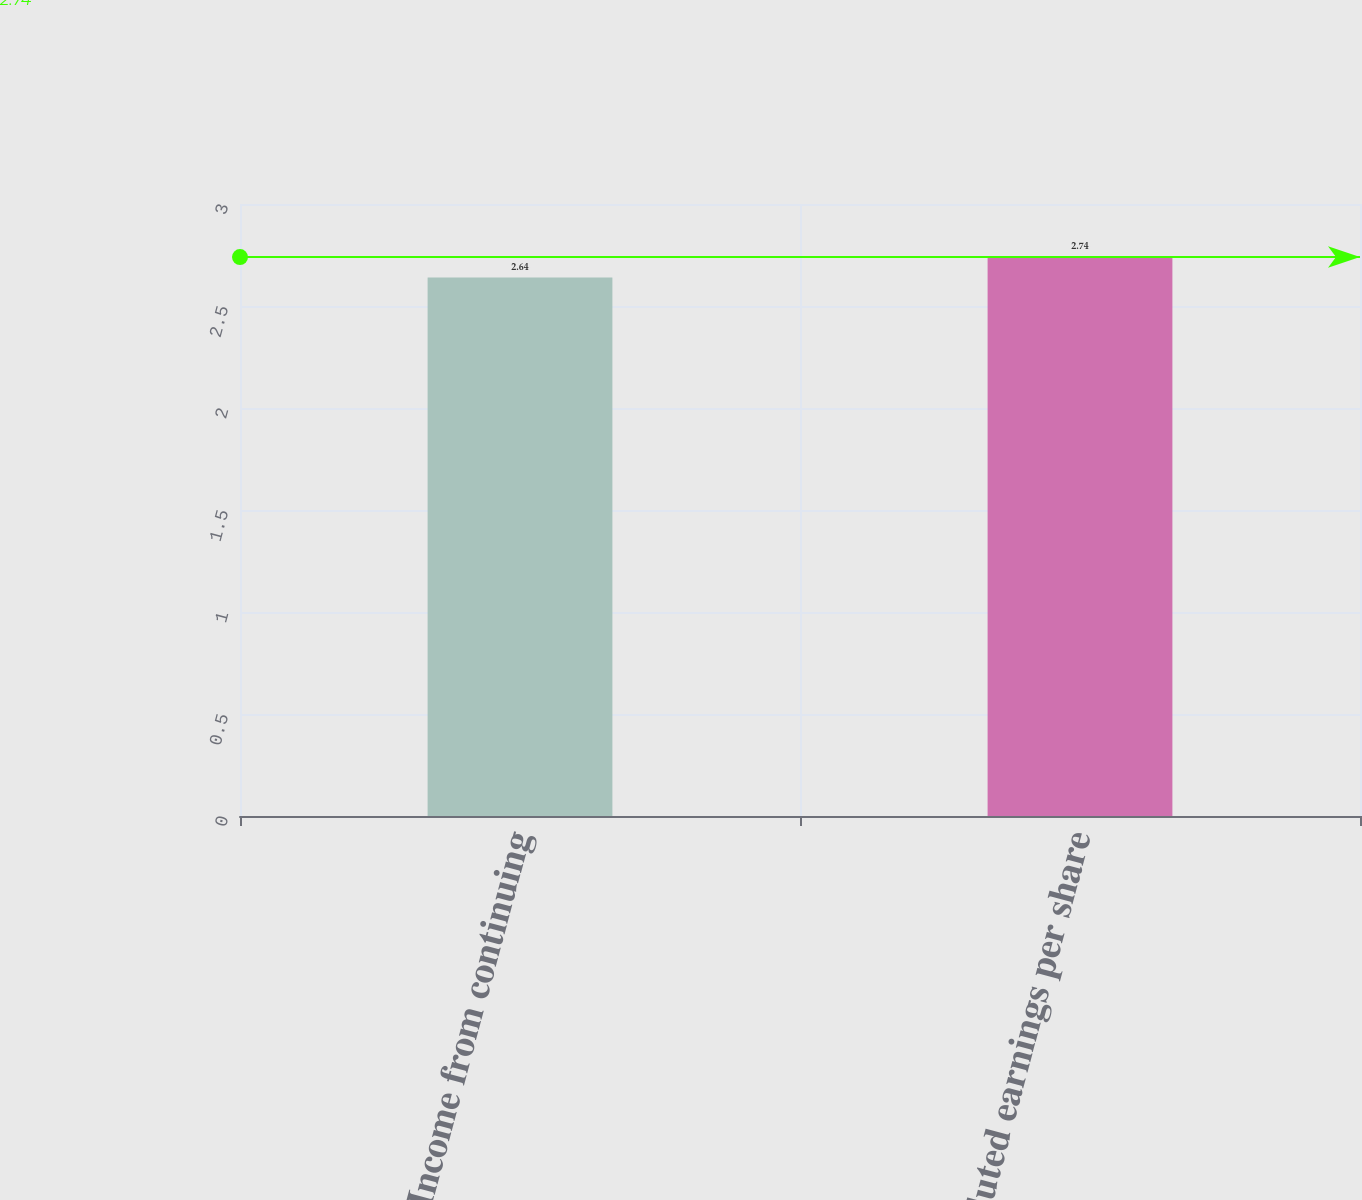Convert chart. <chart><loc_0><loc_0><loc_500><loc_500><bar_chart><fcel>Income from continuing<fcel>Diluted earnings per share<nl><fcel>2.64<fcel>2.74<nl></chart> 